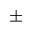<formula> <loc_0><loc_0><loc_500><loc_500>\pm</formula> 